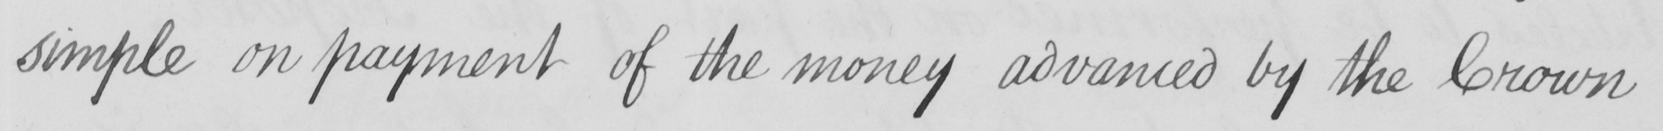Can you tell me what this handwritten text says? simple on payment of the money advanced by the Crown- 